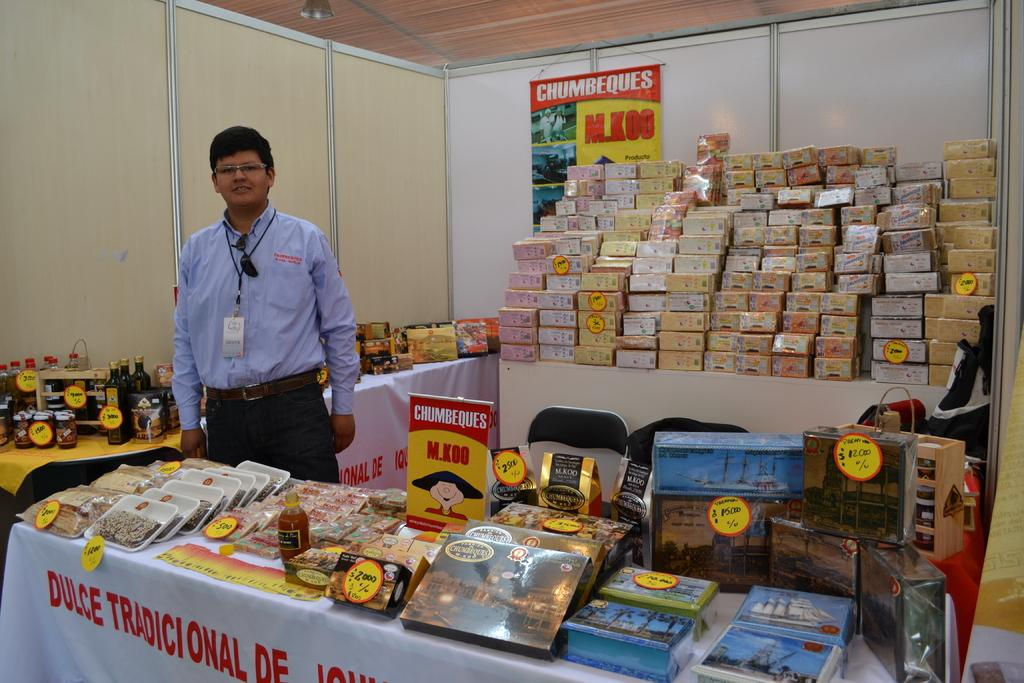<image>
Write a terse but informative summary of the picture. A man behind a table which is advertising Chumbeques M.Koo products 